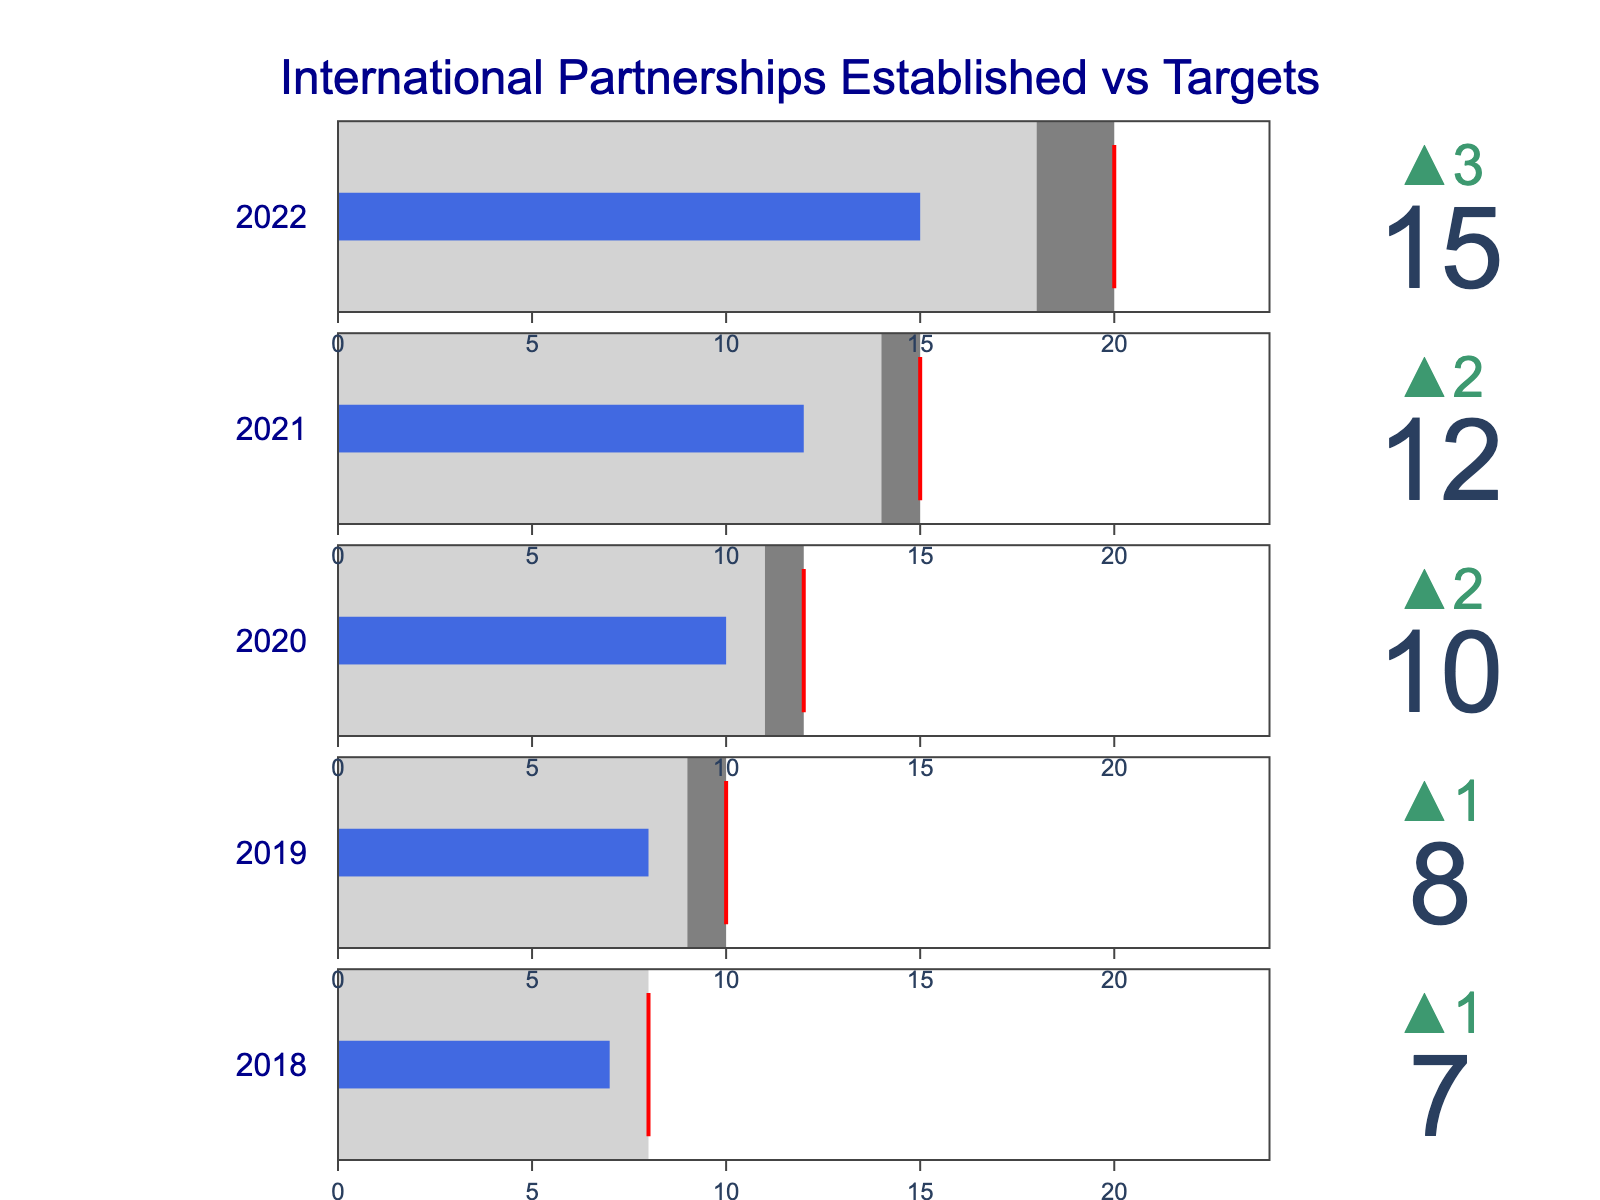What is the highest target value displayed in the bullet chart? The highest target value can be found by identifying the largest target value shown across all years in the chart. The target values are: 20 (2022), 15 (2021), 12 (2020), 10 (2019), and 8 (2018). The highest of these is 20, for the year 2022.
Answer: 20 How did the number of international partnerships established in 2022 compare to the target for that year? Locate the data for 2022 in the chart. The actual number of partnerships established is 15, while the target was 20. The actual value is less than the target by 5 partnerships.
Answer: Less by 5 Which year had the highest increase in partnerships established compared to the previous year? Calculate the increase for each year compared to the previous year: 2022 had an increase of 3 (15-12), 2021 had an increase of 2 (12-10), 2020 had an increase of 2 (10-8), and 2019 had an increase of 1 (8-7). The highest increase is 3, which occurred in 2022.
Answer: 2022 What is the difference between the actual number of partnerships and the benchmark for 2021? Find the actual number and benchmark for 2021. The actual number is 12 and the benchmark is 14. The difference is 12 - 14 = -2.
Answer: -2 In which year did the actual number of partnerships exceed the benchmark value? Compare the actual numbers and benchmarks for each year: 2022 (15 vs 18), 2021 (12 vs 14), 2020 (10 vs 11), 2019 (8 vs 9), 2018 (7 vs 8). For all years, the actual number of partnerships established did not exceed the benchmark.
Answer: None What color represents the actual number of partnerships on the bullet chart for all years? Identify the color associated with the actual value bars in the bullet chart. In the provided script, the 'bar' color for actual values is set to "royalblue".
Answer: Royal blue How many years show that the number of partnerships achieved exceeded the previous year's number? Determine the number of years where the actual value is greater than the previous year's value: 2022 (15 > 12), 2021 (12 > 10), 2020 (10 > 8), 2019 (8 > 7), 2018 (7 > 6). The pattern shows that each year met this criterion.
Answer: All years What trends can be observed in the actual number of partnerships established from 2018 to 2022? By looking at the actual values each year from 2018 to 2022 (7, 8, 10, 12, 15), a consistent increasing trend can be observed in the number of partnerships established over this timeframe.
Answer: Increasing trend How much did the actual value deviate from the target in 2020? Identify the actual and target values for 2020. Actual is 10 and target is 12. The deviation is 12 - 10 = 2 partnerships below the target.
Answer: 2 below 